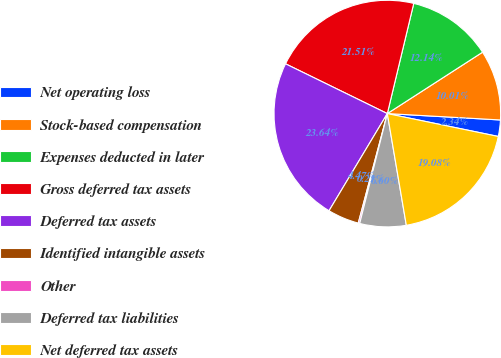<chart> <loc_0><loc_0><loc_500><loc_500><pie_chart><fcel>Net operating loss<fcel>Stock-based compensation<fcel>Expenses deducted in later<fcel>Gross deferred tax assets<fcel>Deferred tax assets<fcel>Identified intangible assets<fcel>Other<fcel>Deferred tax liabilities<fcel>Net deferred tax assets<nl><fcel>2.34%<fcel>10.01%<fcel>12.14%<fcel>21.51%<fcel>23.64%<fcel>4.47%<fcel>0.21%<fcel>6.6%<fcel>19.08%<nl></chart> 